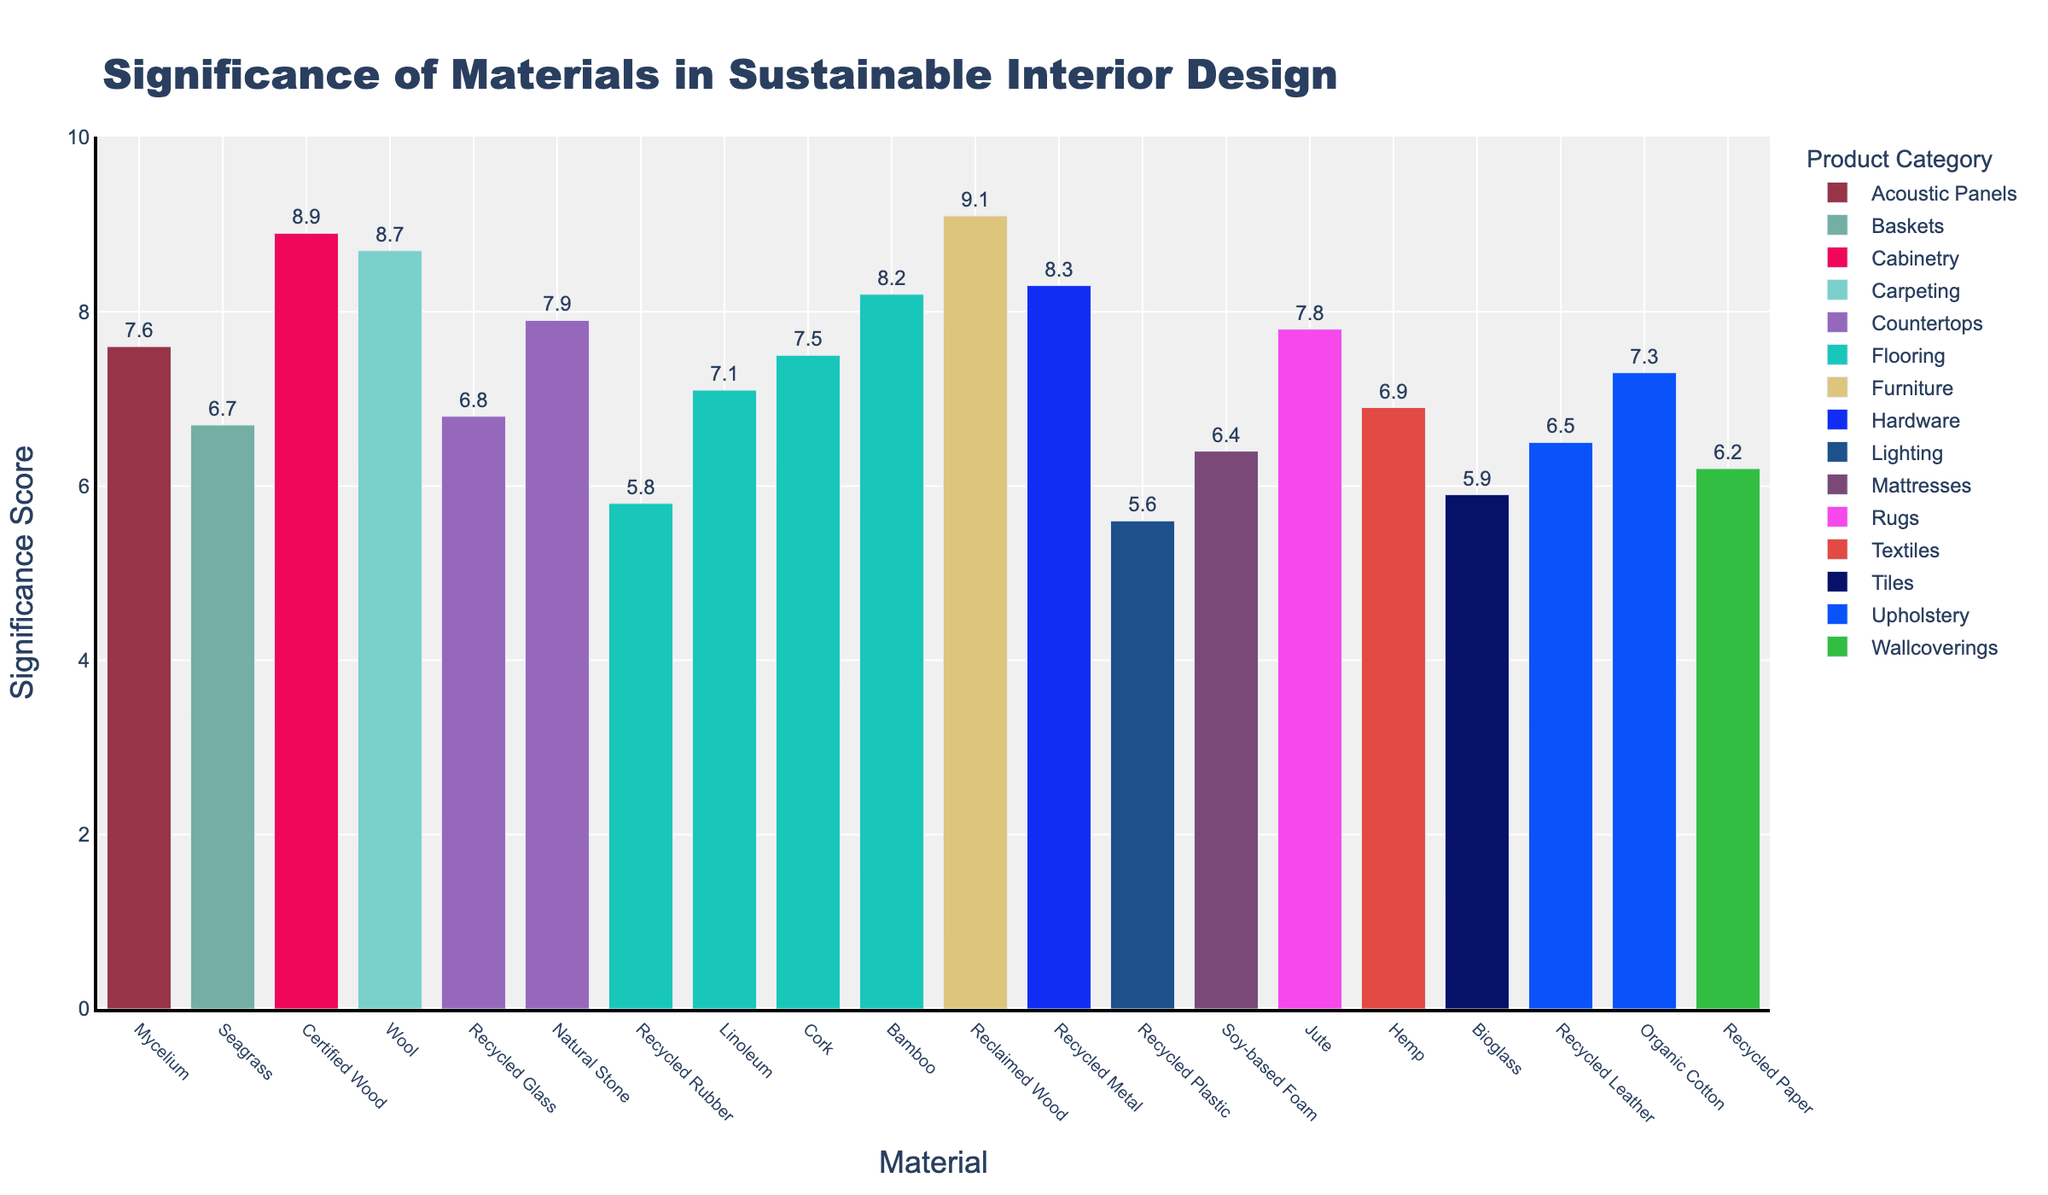Which material has the highest significance in the Furniture category? By looking at the bar heights in the Furniture category, the material with the highest bar is Reclaimed Wood with a significance of 9.1
Answer: Reclaimed Wood What is the significance score for Recycled Metal in Hardware? By locating the bar for Recycled Metal in the Hardware category, we can see the bar is labeled with a significance of 8.3
Answer: 8.3 How does the significance of Organic Cotton in Upholstery compare to Recycled Leather in the same category? Comparing the bar heights for Organic Cotton and Recycled Leather in the Upholstery category, Organic Cotton has a significance of 7.3 while Recycled Leather has 6.5
Answer: Organic Cotton has a higher significance Which Flooring material has the lowest significance score, and what is the score? Among the Flooring category bars, Recycled Rubber has the lowest significance score of 5.8
Answer: Recycled Rubber, 5.8 What is the average significance score of materials in the Countertops category? The Countertops category includes Recycled Glass (6.8) and Natural Stone (7.9). The average is calculated as (6.8 + 7.9) / 2 = 7.35
Answer: 7.35 Is the significance score of Jute in Rugs higher or lower than Soy-based Foam in Mattresses? Comparing the heights of the bars for Jute and Soy-based Foam, Jute (7.8) is higher than Soy-based Foam (6.4)
Answer: Higher Which category has the widest range of significance scores? By examining the ranges of bar heights for each category, Flooring ranges from Recycled Rubber (5.8) to Bamboo (8.2), spanning 2.4 units, which is the widest range
Answer: Flooring What is the difference in significance score between Certified Wood in Cabinetry and Recycled Paper in Wallcoverings? The significance score for Certified Wood (8.9) minus Recycled Paper (6.2) is 8.9 - 6.2 = 2.7
Answer: 2.7 How many different categories are represented in the plot? Counting the distinct category labels in the legend, there are 11 different categories
Answer: 11 